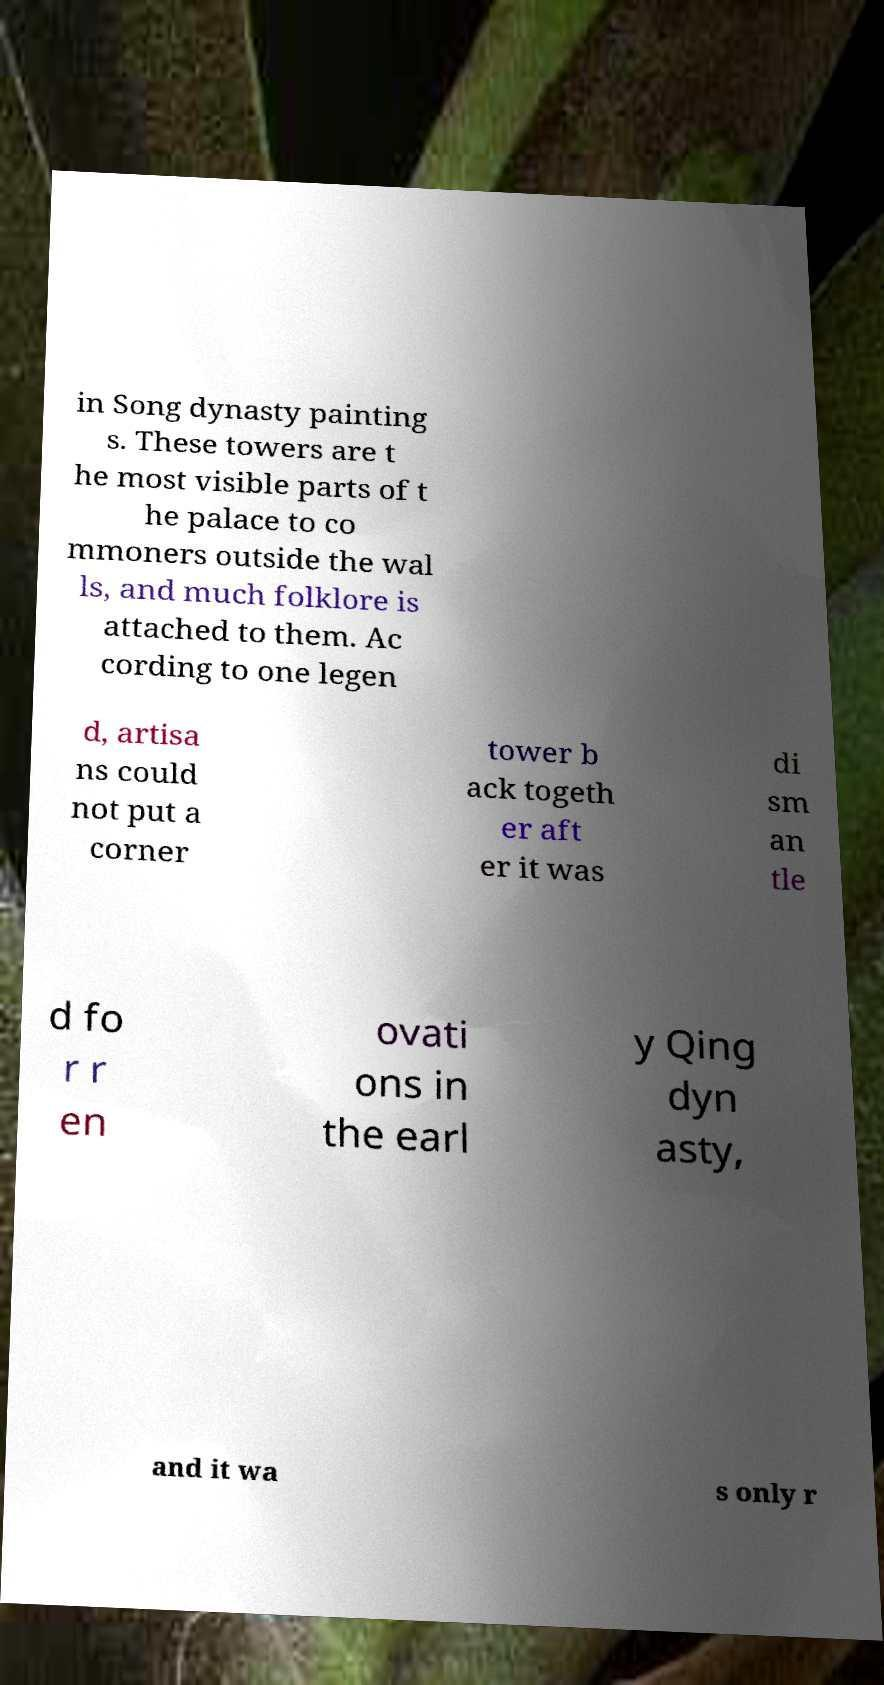Please identify and transcribe the text found in this image. in Song dynasty painting s. These towers are t he most visible parts of t he palace to co mmoners outside the wal ls, and much folklore is attached to them. Ac cording to one legen d, artisa ns could not put a corner tower b ack togeth er aft er it was di sm an tle d fo r r en ovati ons in the earl y Qing dyn asty, and it wa s only r 